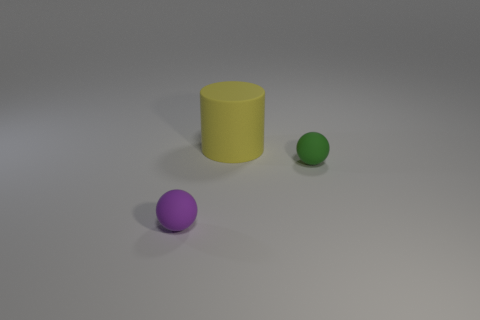Subtract all spheres. How many objects are left? 1 Subtract all green balls. How many green cylinders are left? 0 Subtract all brown metal spheres. Subtract all big yellow objects. How many objects are left? 2 Add 3 balls. How many balls are left? 5 Add 3 red matte balls. How many red matte balls exist? 3 Add 3 small rubber spheres. How many objects exist? 6 Subtract all green spheres. How many spheres are left? 1 Subtract 0 cyan cubes. How many objects are left? 3 Subtract all brown cylinders. Subtract all purple cubes. How many cylinders are left? 1 